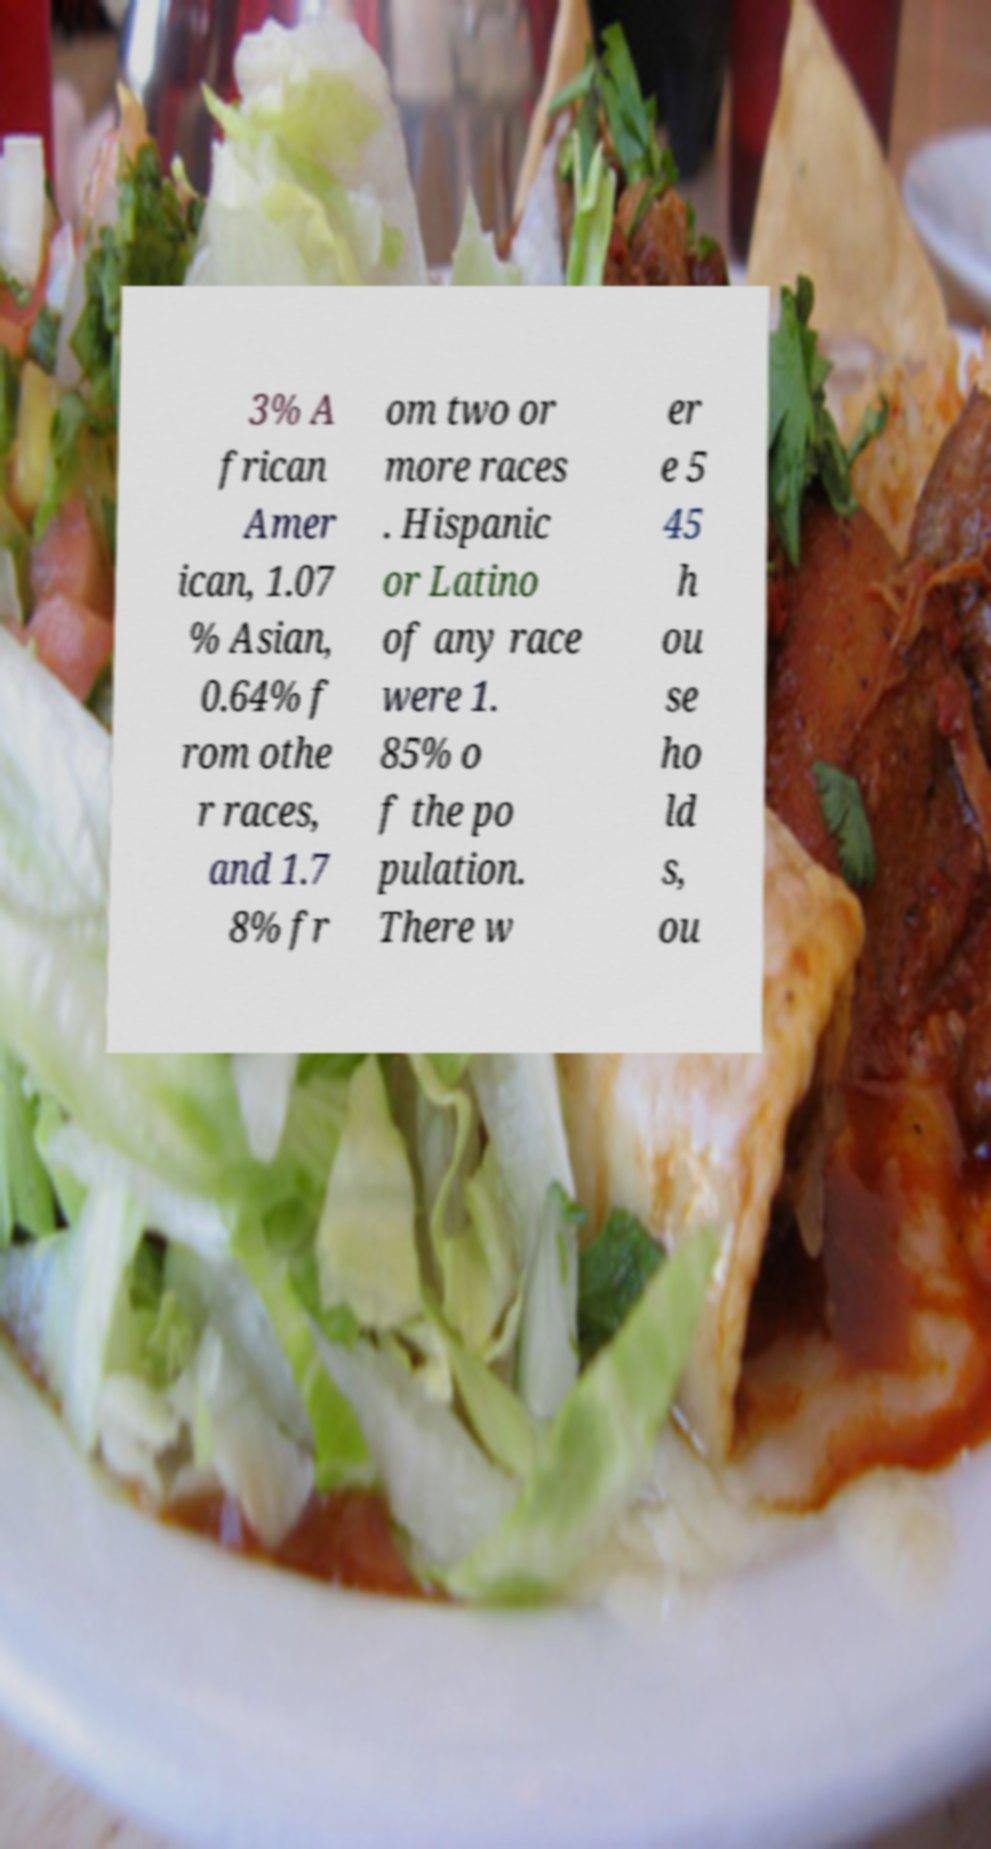Please identify and transcribe the text found in this image. 3% A frican Amer ican, 1.07 % Asian, 0.64% f rom othe r races, and 1.7 8% fr om two or more races . Hispanic or Latino of any race were 1. 85% o f the po pulation. There w er e 5 45 h ou se ho ld s, ou 